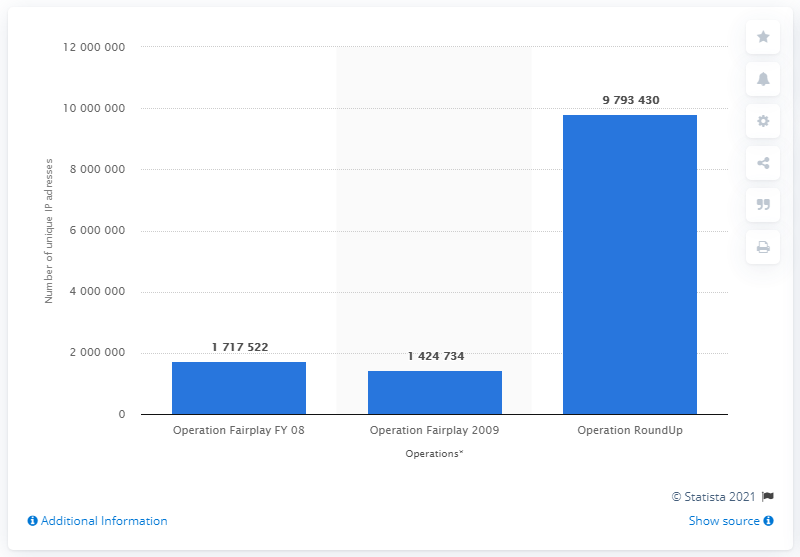Highlight a few significant elements in this photo. In Operation RoundUp in 2009, a total of 979,3430 unique IP addresses were obtained. 